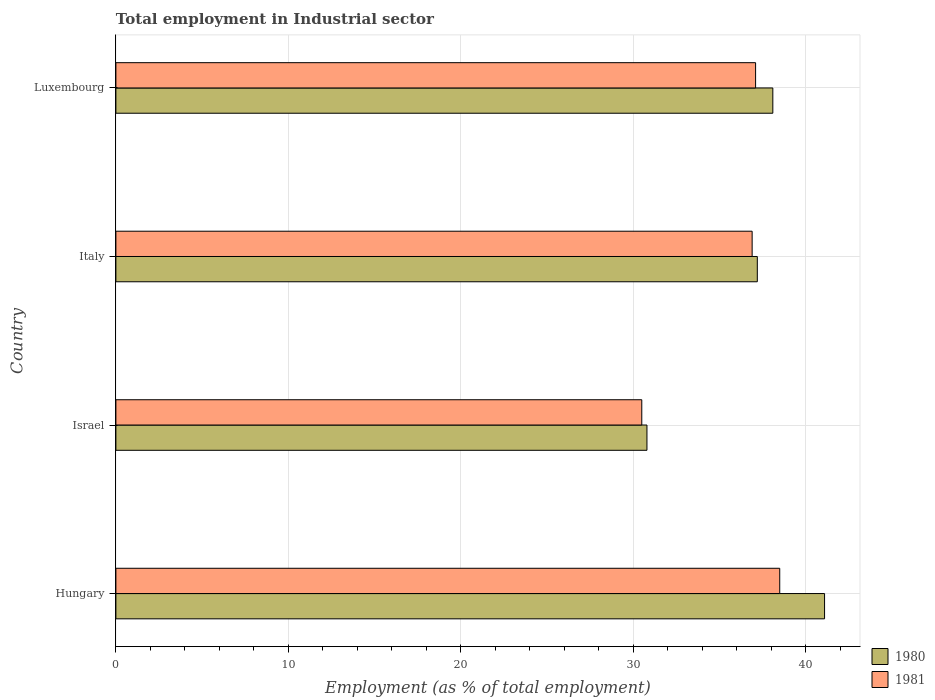Are the number of bars on each tick of the Y-axis equal?
Keep it short and to the point. Yes. How many bars are there on the 2nd tick from the top?
Provide a succinct answer. 2. What is the label of the 4th group of bars from the top?
Your response must be concise. Hungary. In how many cases, is the number of bars for a given country not equal to the number of legend labels?
Your answer should be compact. 0. What is the employment in industrial sector in 1980 in Luxembourg?
Offer a terse response. 38.1. Across all countries, what is the maximum employment in industrial sector in 1980?
Make the answer very short. 41.1. Across all countries, what is the minimum employment in industrial sector in 1981?
Provide a short and direct response. 30.5. In which country was the employment in industrial sector in 1981 maximum?
Give a very brief answer. Hungary. What is the total employment in industrial sector in 1981 in the graph?
Your answer should be compact. 143. What is the difference between the employment in industrial sector in 1980 in Israel and that in Italy?
Your answer should be very brief. -6.4. What is the difference between the employment in industrial sector in 1980 in Italy and the employment in industrial sector in 1981 in Hungary?
Your answer should be compact. -1.3. What is the average employment in industrial sector in 1980 per country?
Make the answer very short. 36.8. What is the difference between the employment in industrial sector in 1981 and employment in industrial sector in 1980 in Italy?
Make the answer very short. -0.3. What is the ratio of the employment in industrial sector in 1981 in Hungary to that in Italy?
Make the answer very short. 1.04. In how many countries, is the employment in industrial sector in 1980 greater than the average employment in industrial sector in 1980 taken over all countries?
Make the answer very short. 3. What does the 1st bar from the top in Hungary represents?
Keep it short and to the point. 1981. What does the 1st bar from the bottom in Israel represents?
Offer a terse response. 1980. How many bars are there?
Your answer should be very brief. 8. Are all the bars in the graph horizontal?
Provide a short and direct response. Yes. Are the values on the major ticks of X-axis written in scientific E-notation?
Make the answer very short. No. Where does the legend appear in the graph?
Give a very brief answer. Bottom right. How many legend labels are there?
Your answer should be compact. 2. How are the legend labels stacked?
Your answer should be very brief. Vertical. What is the title of the graph?
Make the answer very short. Total employment in Industrial sector. Does "2001" appear as one of the legend labels in the graph?
Provide a succinct answer. No. What is the label or title of the X-axis?
Offer a terse response. Employment (as % of total employment). What is the label or title of the Y-axis?
Ensure brevity in your answer.  Country. What is the Employment (as % of total employment) in 1980 in Hungary?
Ensure brevity in your answer.  41.1. What is the Employment (as % of total employment) in 1981 in Hungary?
Provide a succinct answer. 38.5. What is the Employment (as % of total employment) in 1980 in Israel?
Keep it short and to the point. 30.8. What is the Employment (as % of total employment) of 1981 in Israel?
Provide a short and direct response. 30.5. What is the Employment (as % of total employment) of 1980 in Italy?
Ensure brevity in your answer.  37.2. What is the Employment (as % of total employment) in 1981 in Italy?
Ensure brevity in your answer.  36.9. What is the Employment (as % of total employment) of 1980 in Luxembourg?
Provide a succinct answer. 38.1. What is the Employment (as % of total employment) of 1981 in Luxembourg?
Ensure brevity in your answer.  37.1. Across all countries, what is the maximum Employment (as % of total employment) in 1980?
Offer a very short reply. 41.1. Across all countries, what is the maximum Employment (as % of total employment) in 1981?
Your answer should be compact. 38.5. Across all countries, what is the minimum Employment (as % of total employment) in 1980?
Your answer should be compact. 30.8. Across all countries, what is the minimum Employment (as % of total employment) of 1981?
Offer a terse response. 30.5. What is the total Employment (as % of total employment) in 1980 in the graph?
Give a very brief answer. 147.2. What is the total Employment (as % of total employment) of 1981 in the graph?
Offer a very short reply. 143. What is the difference between the Employment (as % of total employment) of 1981 in Hungary and that in Israel?
Offer a very short reply. 8. What is the difference between the Employment (as % of total employment) in 1980 in Hungary and that in Italy?
Provide a succinct answer. 3.9. What is the difference between the Employment (as % of total employment) in 1981 in Hungary and that in Italy?
Ensure brevity in your answer.  1.6. What is the difference between the Employment (as % of total employment) of 1980 in Hungary and that in Luxembourg?
Offer a terse response. 3. What is the difference between the Employment (as % of total employment) of 1980 in Israel and that in Italy?
Give a very brief answer. -6.4. What is the difference between the Employment (as % of total employment) in 1981 in Israel and that in Italy?
Keep it short and to the point. -6.4. What is the difference between the Employment (as % of total employment) of 1980 in Italy and that in Luxembourg?
Your answer should be very brief. -0.9. What is the difference between the Employment (as % of total employment) in 1981 in Italy and that in Luxembourg?
Provide a succinct answer. -0.2. What is the difference between the Employment (as % of total employment) in 1980 in Hungary and the Employment (as % of total employment) in 1981 in Israel?
Offer a very short reply. 10.6. What is the difference between the Employment (as % of total employment) in 1980 in Hungary and the Employment (as % of total employment) in 1981 in Italy?
Provide a succinct answer. 4.2. What is the difference between the Employment (as % of total employment) in 1980 in Israel and the Employment (as % of total employment) in 1981 in Italy?
Provide a succinct answer. -6.1. What is the difference between the Employment (as % of total employment) in 1980 in Israel and the Employment (as % of total employment) in 1981 in Luxembourg?
Keep it short and to the point. -6.3. What is the difference between the Employment (as % of total employment) of 1980 in Italy and the Employment (as % of total employment) of 1981 in Luxembourg?
Ensure brevity in your answer.  0.1. What is the average Employment (as % of total employment) of 1980 per country?
Offer a very short reply. 36.8. What is the average Employment (as % of total employment) of 1981 per country?
Offer a very short reply. 35.75. What is the difference between the Employment (as % of total employment) of 1980 and Employment (as % of total employment) of 1981 in Hungary?
Give a very brief answer. 2.6. What is the difference between the Employment (as % of total employment) of 1980 and Employment (as % of total employment) of 1981 in Luxembourg?
Provide a succinct answer. 1. What is the ratio of the Employment (as % of total employment) of 1980 in Hungary to that in Israel?
Give a very brief answer. 1.33. What is the ratio of the Employment (as % of total employment) of 1981 in Hungary to that in Israel?
Offer a terse response. 1.26. What is the ratio of the Employment (as % of total employment) in 1980 in Hungary to that in Italy?
Provide a succinct answer. 1.1. What is the ratio of the Employment (as % of total employment) in 1981 in Hungary to that in Italy?
Provide a succinct answer. 1.04. What is the ratio of the Employment (as % of total employment) in 1980 in Hungary to that in Luxembourg?
Keep it short and to the point. 1.08. What is the ratio of the Employment (as % of total employment) in 1981 in Hungary to that in Luxembourg?
Keep it short and to the point. 1.04. What is the ratio of the Employment (as % of total employment) in 1980 in Israel to that in Italy?
Offer a terse response. 0.83. What is the ratio of the Employment (as % of total employment) of 1981 in Israel to that in Italy?
Ensure brevity in your answer.  0.83. What is the ratio of the Employment (as % of total employment) of 1980 in Israel to that in Luxembourg?
Ensure brevity in your answer.  0.81. What is the ratio of the Employment (as % of total employment) of 1981 in Israel to that in Luxembourg?
Offer a terse response. 0.82. What is the ratio of the Employment (as % of total employment) in 1980 in Italy to that in Luxembourg?
Your answer should be very brief. 0.98. What is the difference between the highest and the second highest Employment (as % of total employment) in 1980?
Keep it short and to the point. 3. 